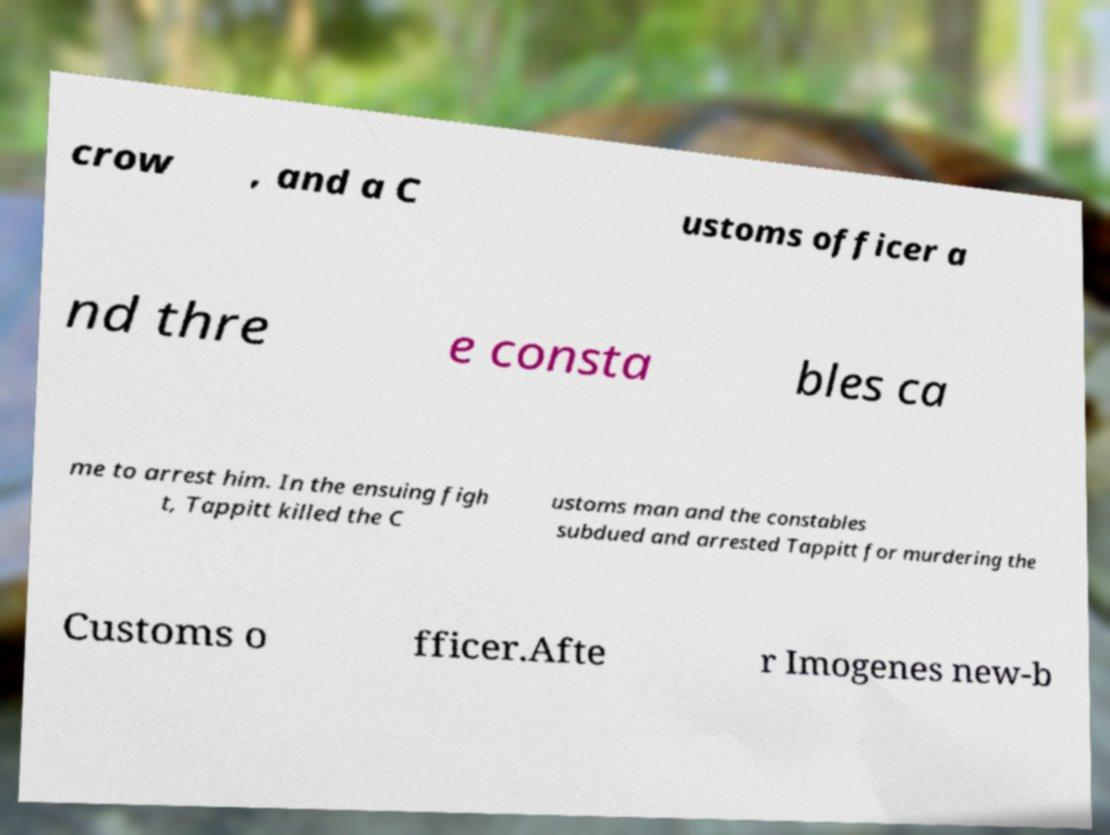There's text embedded in this image that I need extracted. Can you transcribe it verbatim? crow , and a C ustoms officer a nd thre e consta bles ca me to arrest him. In the ensuing figh t, Tappitt killed the C ustoms man and the constables subdued and arrested Tappitt for murdering the Customs o fficer.Afte r Imogenes new-b 